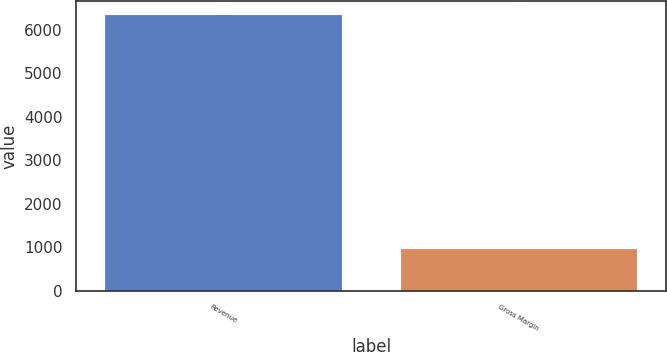<chart> <loc_0><loc_0><loc_500><loc_500><bar_chart><fcel>Revenue<fcel>Gross Margin<nl><fcel>6340<fcel>968<nl></chart> 